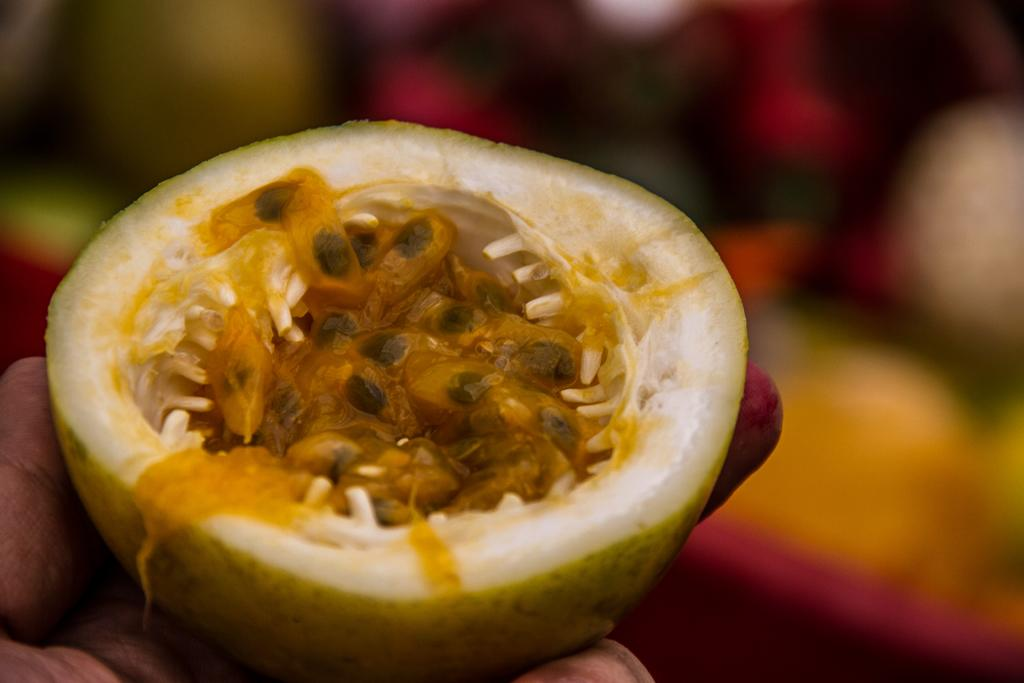What is present in the image? There is a person in the image. What is the person holding in their hands? The person is holding fruit in their hands. Can you see any goats in the image? No, there are no goats present in the image. How many planes are visible in the image? There are no planes visible in the image. 